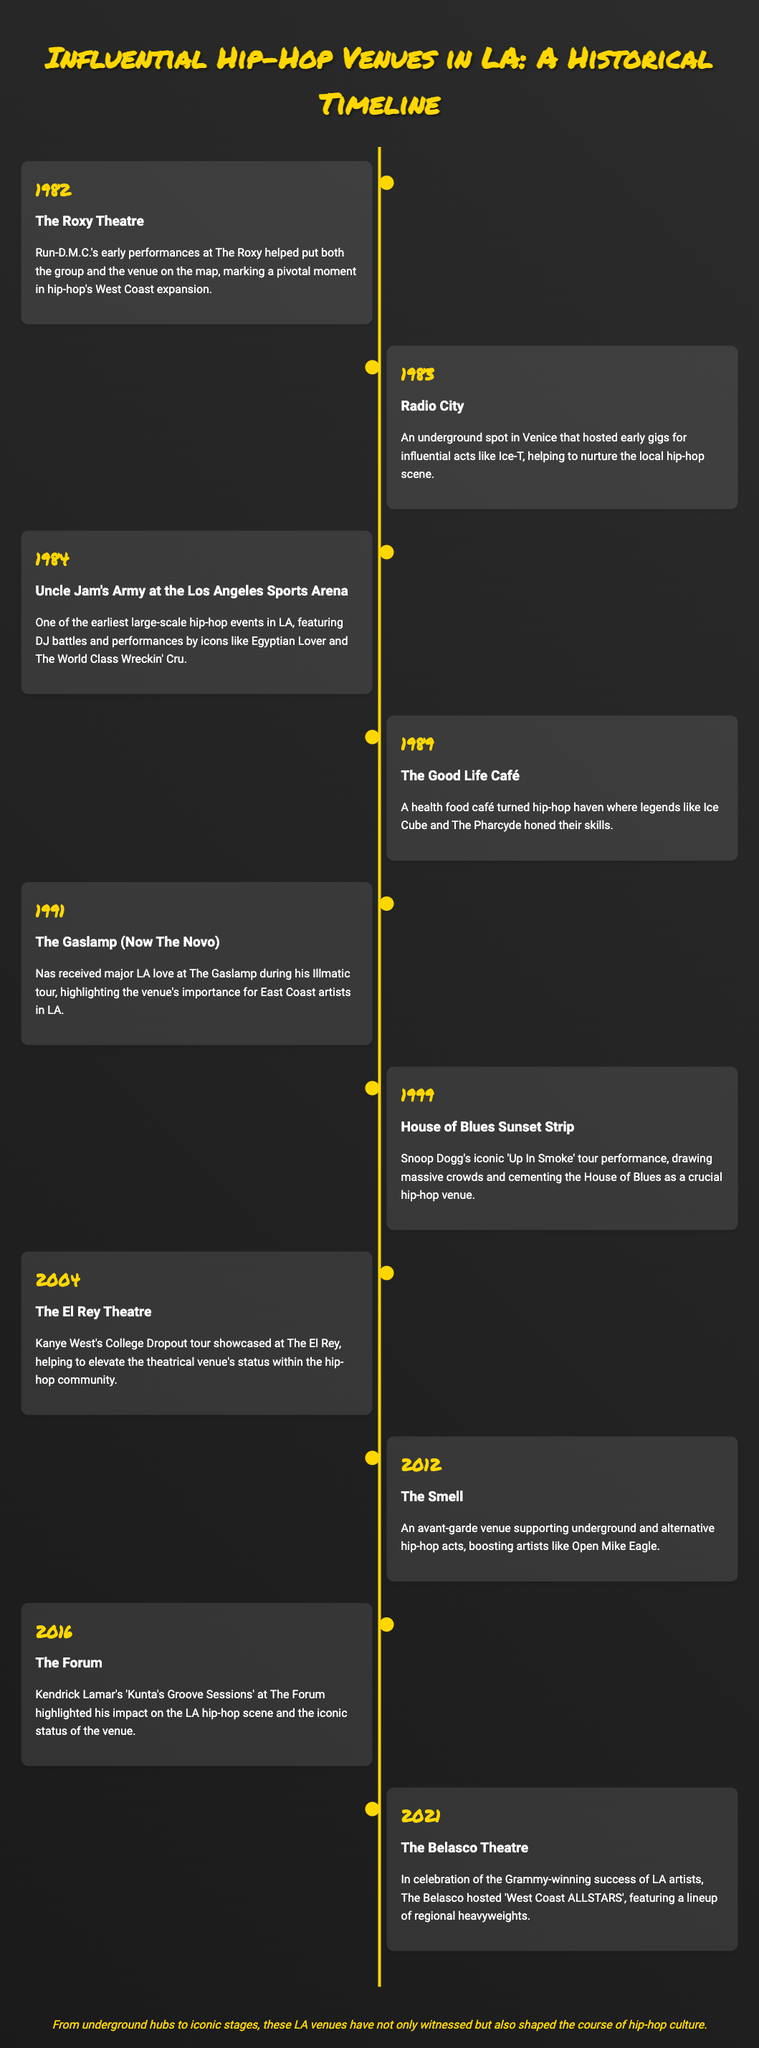What venue hosted Run-D.M.C.'s early performances? The document states that The Roxy Theatre hosted Run-D.M.C.'s early performances, marking a pivotal moment in hip-hop's West Coast expansion.
Answer: The Roxy Theatre In what year did Kendrick Lamar perform at The Forum? According to the timeline, Kendrick Lamar performed at The Forum in 2016 as part of 'Kunta's Groove Sessions'.
Answer: 2016 Which venue is known as an underground spot in Venice? The document mentions Radio City as an underground spot in Venice that hosted early gigs for influential acts like Ice-T.
Answer: Radio City What influential act performed at The El Rey Theatre in 2004? The timeline highlights Kanye West's College Dropout tour showcased at The El Rey Theatre, elevating its status within the hip-hop community.
Answer: Kanye West What year did Snoop Dogg's 'Up In Smoke' tour take place? The document states that Snoop Dogg's iconic 'Up In Smoke' tour performance was in 1999 at the House of Blues Sunset Strip.
Answer: 1999 Which café turned hip-hop haven featured legends like Ice Cube? The timeline indicates that The Good Life Café, which was a health food café turned hip-hop haven, featured legends like Ice Cube and The Pharcyde.
Answer: The Good Life Café Which venue hosted 'West Coast ALLSTARS' in 2021? The Belasco Theatre hosted the 'West Coast ALLSTARS' event in celebration of the Grammy-winning success of LA artists in 2021.
Answer: The Belasco Theatre What title is associated with the event at The Gaslamp in 1991? The document specifies that Nas received major LA love at The Gaslamp during his Illmatic tour in 1991, highlighting the venue's importance for East Coast artists in LA.
Answer: Illmatic tour 